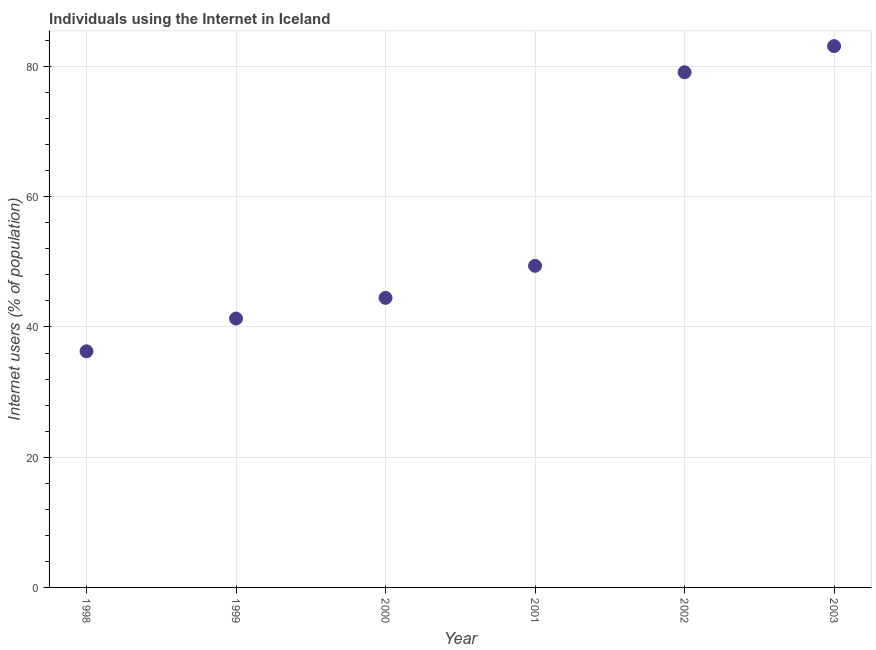What is the number of internet users in 2003?
Provide a short and direct response. 83.14. Across all years, what is the maximum number of internet users?
Provide a succinct answer. 83.14. Across all years, what is the minimum number of internet users?
Your answer should be very brief. 36.26. In which year was the number of internet users maximum?
Give a very brief answer. 2003. What is the sum of the number of internet users?
Offer a very short reply. 333.68. What is the difference between the number of internet users in 2001 and 2003?
Provide a short and direct response. -33.75. What is the average number of internet users per year?
Ensure brevity in your answer.  55.61. What is the median number of internet users?
Your answer should be very brief. 46.93. In how many years, is the number of internet users greater than 4 %?
Keep it short and to the point. 6. What is the ratio of the number of internet users in 1999 to that in 2001?
Your answer should be compact. 0.84. Is the difference between the number of internet users in 1999 and 2003 greater than the difference between any two years?
Your answer should be very brief. No. What is the difference between the highest and the second highest number of internet users?
Keep it short and to the point. 4.02. Is the sum of the number of internet users in 2001 and 2002 greater than the maximum number of internet users across all years?
Your response must be concise. Yes. What is the difference between the highest and the lowest number of internet users?
Keep it short and to the point. 46.88. In how many years, is the number of internet users greater than the average number of internet users taken over all years?
Provide a succinct answer. 2. How many years are there in the graph?
Ensure brevity in your answer.  6. What is the difference between two consecutive major ticks on the Y-axis?
Provide a short and direct response. 20. What is the title of the graph?
Provide a succinct answer. Individuals using the Internet in Iceland. What is the label or title of the X-axis?
Your answer should be very brief. Year. What is the label or title of the Y-axis?
Your response must be concise. Internet users (% of population). What is the Internet users (% of population) in 1998?
Your response must be concise. 36.26. What is the Internet users (% of population) in 1999?
Provide a short and direct response. 41.29. What is the Internet users (% of population) in 2000?
Your answer should be compact. 44.47. What is the Internet users (% of population) in 2001?
Make the answer very short. 49.39. What is the Internet users (% of population) in 2002?
Your answer should be compact. 79.12. What is the Internet users (% of population) in 2003?
Offer a very short reply. 83.14. What is the difference between the Internet users (% of population) in 1998 and 1999?
Give a very brief answer. -5.03. What is the difference between the Internet users (% of population) in 1998 and 2000?
Your response must be concise. -8.21. What is the difference between the Internet users (% of population) in 1998 and 2001?
Make the answer very short. -13.13. What is the difference between the Internet users (% of population) in 1998 and 2002?
Your answer should be very brief. -42.86. What is the difference between the Internet users (% of population) in 1998 and 2003?
Provide a succinct answer. -46.88. What is the difference between the Internet users (% of population) in 1999 and 2000?
Offer a very short reply. -3.18. What is the difference between the Internet users (% of population) in 1999 and 2001?
Your response must be concise. -8.1. What is the difference between the Internet users (% of population) in 1999 and 2002?
Offer a very short reply. -37.83. What is the difference between the Internet users (% of population) in 1999 and 2003?
Provide a succinct answer. -41.85. What is the difference between the Internet users (% of population) in 2000 and 2001?
Offer a very short reply. -4.92. What is the difference between the Internet users (% of population) in 2000 and 2002?
Give a very brief answer. -34.65. What is the difference between the Internet users (% of population) in 2000 and 2003?
Offer a very short reply. -38.67. What is the difference between the Internet users (% of population) in 2001 and 2002?
Make the answer very short. -29.73. What is the difference between the Internet users (% of population) in 2001 and 2003?
Provide a short and direct response. -33.75. What is the difference between the Internet users (% of population) in 2002 and 2003?
Make the answer very short. -4.02. What is the ratio of the Internet users (% of population) in 1998 to that in 1999?
Your answer should be very brief. 0.88. What is the ratio of the Internet users (% of population) in 1998 to that in 2000?
Give a very brief answer. 0.81. What is the ratio of the Internet users (% of population) in 1998 to that in 2001?
Your answer should be compact. 0.73. What is the ratio of the Internet users (% of population) in 1998 to that in 2002?
Your answer should be compact. 0.46. What is the ratio of the Internet users (% of population) in 1998 to that in 2003?
Offer a terse response. 0.44. What is the ratio of the Internet users (% of population) in 1999 to that in 2000?
Your answer should be compact. 0.93. What is the ratio of the Internet users (% of population) in 1999 to that in 2001?
Give a very brief answer. 0.84. What is the ratio of the Internet users (% of population) in 1999 to that in 2002?
Keep it short and to the point. 0.52. What is the ratio of the Internet users (% of population) in 1999 to that in 2003?
Provide a short and direct response. 0.5. What is the ratio of the Internet users (% of population) in 2000 to that in 2002?
Provide a short and direct response. 0.56. What is the ratio of the Internet users (% of population) in 2000 to that in 2003?
Provide a succinct answer. 0.54. What is the ratio of the Internet users (% of population) in 2001 to that in 2002?
Provide a short and direct response. 0.62. What is the ratio of the Internet users (% of population) in 2001 to that in 2003?
Provide a succinct answer. 0.59. What is the ratio of the Internet users (% of population) in 2002 to that in 2003?
Your answer should be compact. 0.95. 